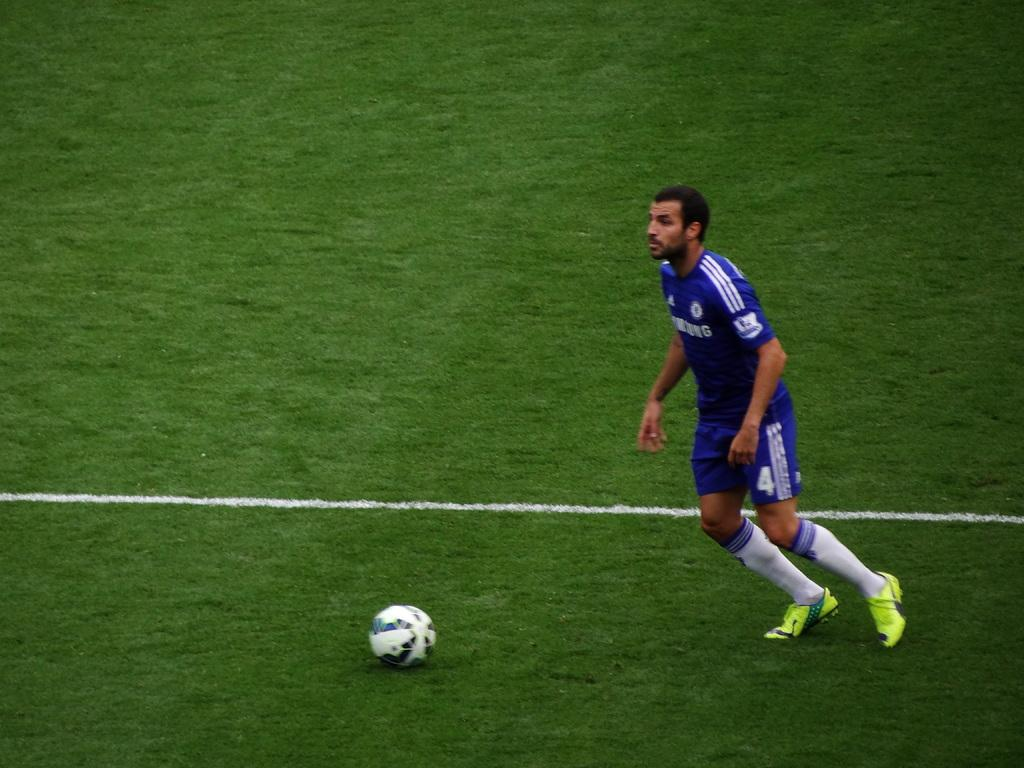Provide a one-sentence caption for the provided image. Soccer player number 4 runs towards a soccer ball sitting in the field. 